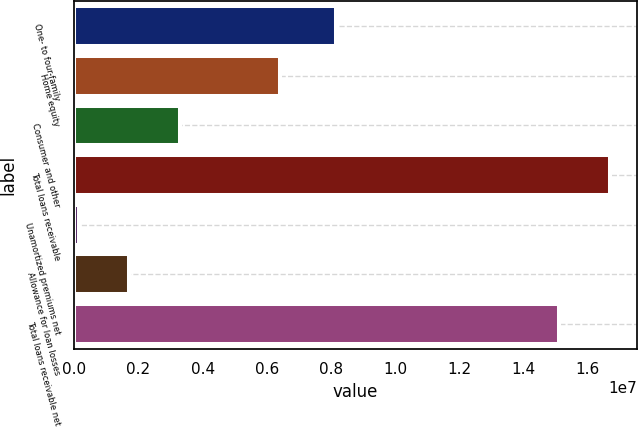Convert chart to OTSL. <chart><loc_0><loc_0><loc_500><loc_500><bar_chart><fcel>One- to four-family<fcel>Home equity<fcel>Consumer and other<fcel>Total loans receivable<fcel>Unamortized premiums net<fcel>Allowance for loan losses<fcel>Total loans receivable net<nl><fcel>8.17033e+06<fcel>6.41031e+06<fcel>3.30805e+06<fcel>1.67114e+07<fcel>129050<fcel>1.71855e+06<fcel>1.51219e+07<nl></chart> 